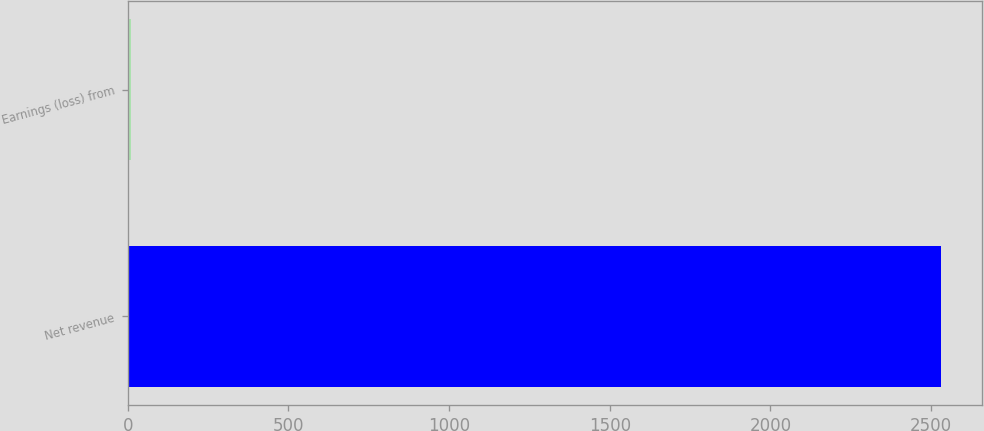Convert chart. <chart><loc_0><loc_0><loc_500><loc_500><bar_chart><fcel>Net revenue<fcel>Earnings (loss) from<nl><fcel>2531<fcel>8.7<nl></chart> 